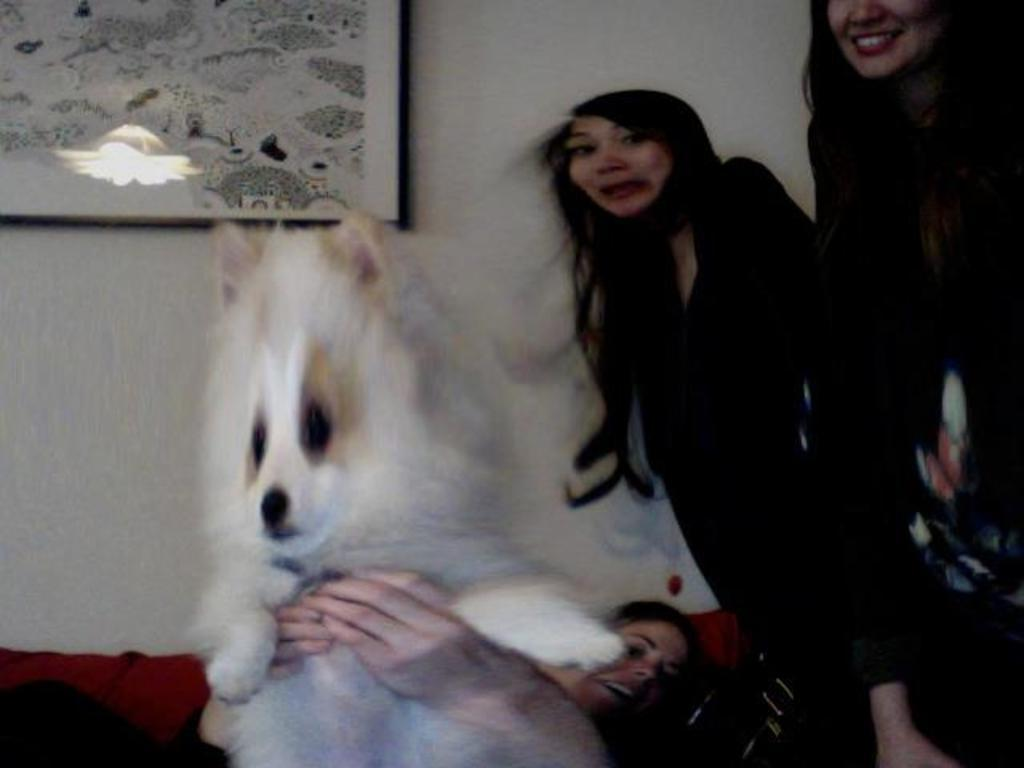How many people are in the image? There are three women in the image. What is one of the women doing with her hands? One woman is holding a dog in her hands. What can be seen in the background of the image? There is a wall painting in the background of the image. Is there an island visible in the image? No, there is no island present in the image. Can you see a visitor holding an umbrella in the image? No, there is no visitor holding an umbrella in the image. 